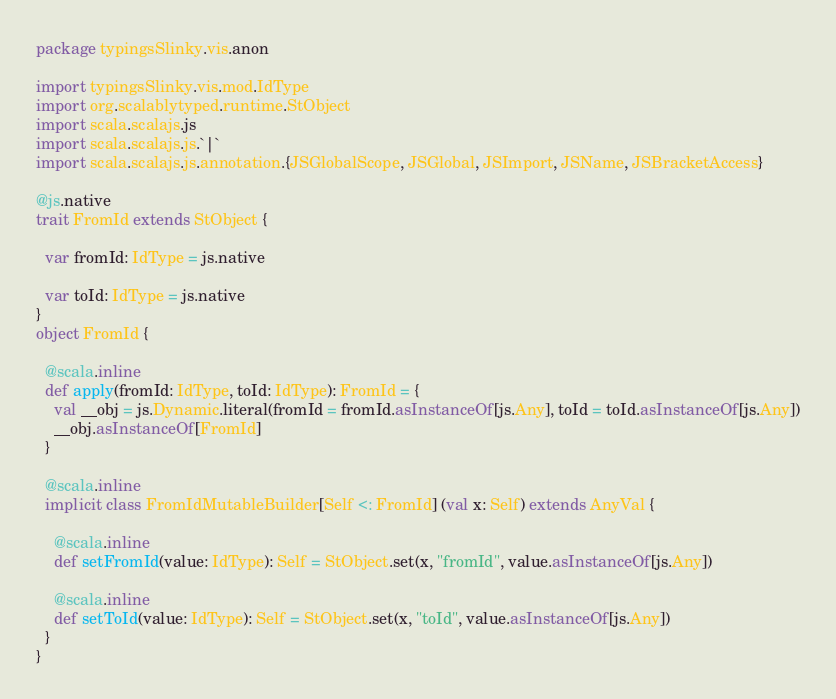Convert code to text. <code><loc_0><loc_0><loc_500><loc_500><_Scala_>package typingsSlinky.vis.anon

import typingsSlinky.vis.mod.IdType
import org.scalablytyped.runtime.StObject
import scala.scalajs.js
import scala.scalajs.js.`|`
import scala.scalajs.js.annotation.{JSGlobalScope, JSGlobal, JSImport, JSName, JSBracketAccess}

@js.native
trait FromId extends StObject {
  
  var fromId: IdType = js.native
  
  var toId: IdType = js.native
}
object FromId {
  
  @scala.inline
  def apply(fromId: IdType, toId: IdType): FromId = {
    val __obj = js.Dynamic.literal(fromId = fromId.asInstanceOf[js.Any], toId = toId.asInstanceOf[js.Any])
    __obj.asInstanceOf[FromId]
  }
  
  @scala.inline
  implicit class FromIdMutableBuilder[Self <: FromId] (val x: Self) extends AnyVal {
    
    @scala.inline
    def setFromId(value: IdType): Self = StObject.set(x, "fromId", value.asInstanceOf[js.Any])
    
    @scala.inline
    def setToId(value: IdType): Self = StObject.set(x, "toId", value.asInstanceOf[js.Any])
  }
}
</code> 